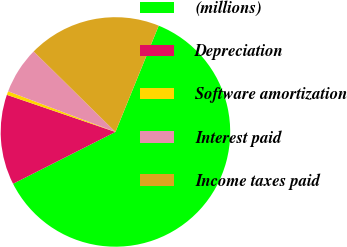<chart> <loc_0><loc_0><loc_500><loc_500><pie_chart><fcel>(millions)<fcel>Depreciation<fcel>Software amortization<fcel>Interest paid<fcel>Income taxes paid<nl><fcel>61.39%<fcel>12.7%<fcel>0.52%<fcel>6.61%<fcel>18.78%<nl></chart> 